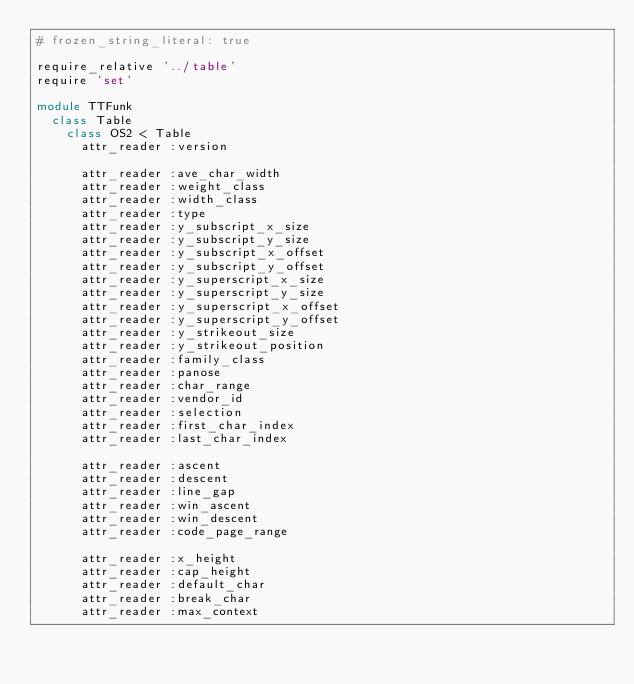<code> <loc_0><loc_0><loc_500><loc_500><_Ruby_># frozen_string_literal: true

require_relative '../table'
require 'set'

module TTFunk
  class Table
    class OS2 < Table
      attr_reader :version

      attr_reader :ave_char_width
      attr_reader :weight_class
      attr_reader :width_class
      attr_reader :type
      attr_reader :y_subscript_x_size
      attr_reader :y_subscript_y_size
      attr_reader :y_subscript_x_offset
      attr_reader :y_subscript_y_offset
      attr_reader :y_superscript_x_size
      attr_reader :y_superscript_y_size
      attr_reader :y_superscript_x_offset
      attr_reader :y_superscript_y_offset
      attr_reader :y_strikeout_size
      attr_reader :y_strikeout_position
      attr_reader :family_class
      attr_reader :panose
      attr_reader :char_range
      attr_reader :vendor_id
      attr_reader :selection
      attr_reader :first_char_index
      attr_reader :last_char_index

      attr_reader :ascent
      attr_reader :descent
      attr_reader :line_gap
      attr_reader :win_ascent
      attr_reader :win_descent
      attr_reader :code_page_range

      attr_reader :x_height
      attr_reader :cap_height
      attr_reader :default_char
      attr_reader :break_char
      attr_reader :max_context
</code> 